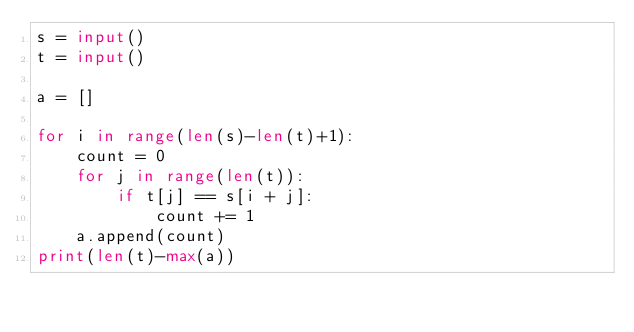<code> <loc_0><loc_0><loc_500><loc_500><_Python_>s = input()
t = input()

a = []

for i in range(len(s)-len(t)+1):
    count = 0
    for j in range(len(t)):
        if t[j] == s[i + j]:
            count += 1
    a.append(count)
print(len(t)-max(a))</code> 